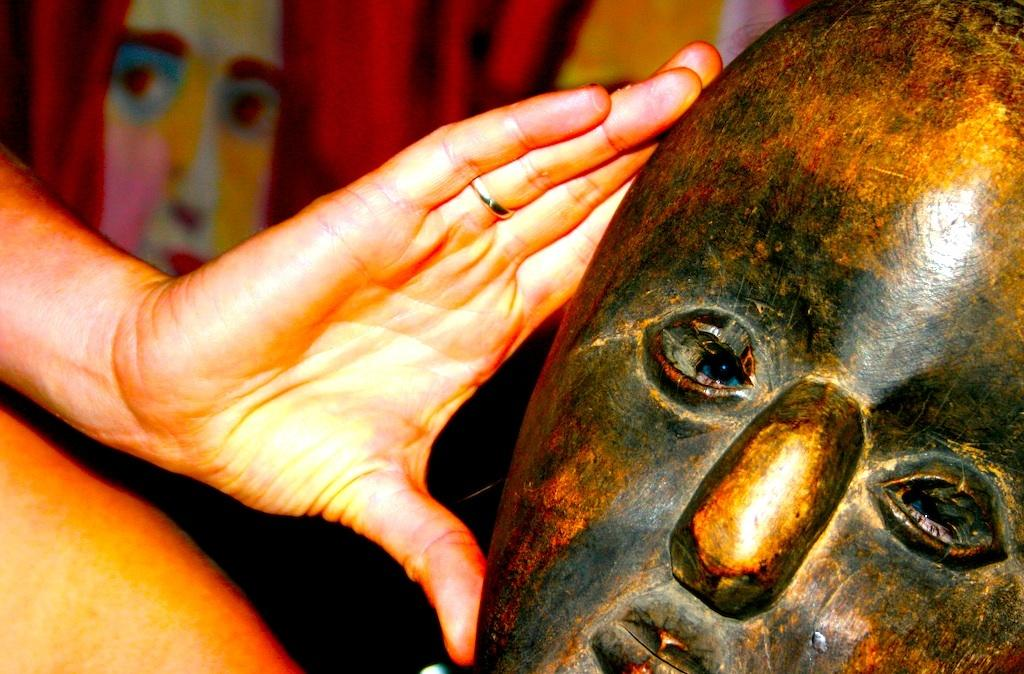What object is located on the right side of the image? There is a mask in the image, and it is on the right side. What part of a human body is visible on the left side of the image? The hand of a human is visible on the left side of the image. What type of earthquake can be seen in the image? There is no earthquake present in the image. What advice is the hand of the human giving in the image? There is no advice being given in the image; it simply shows a hand on the left side. 